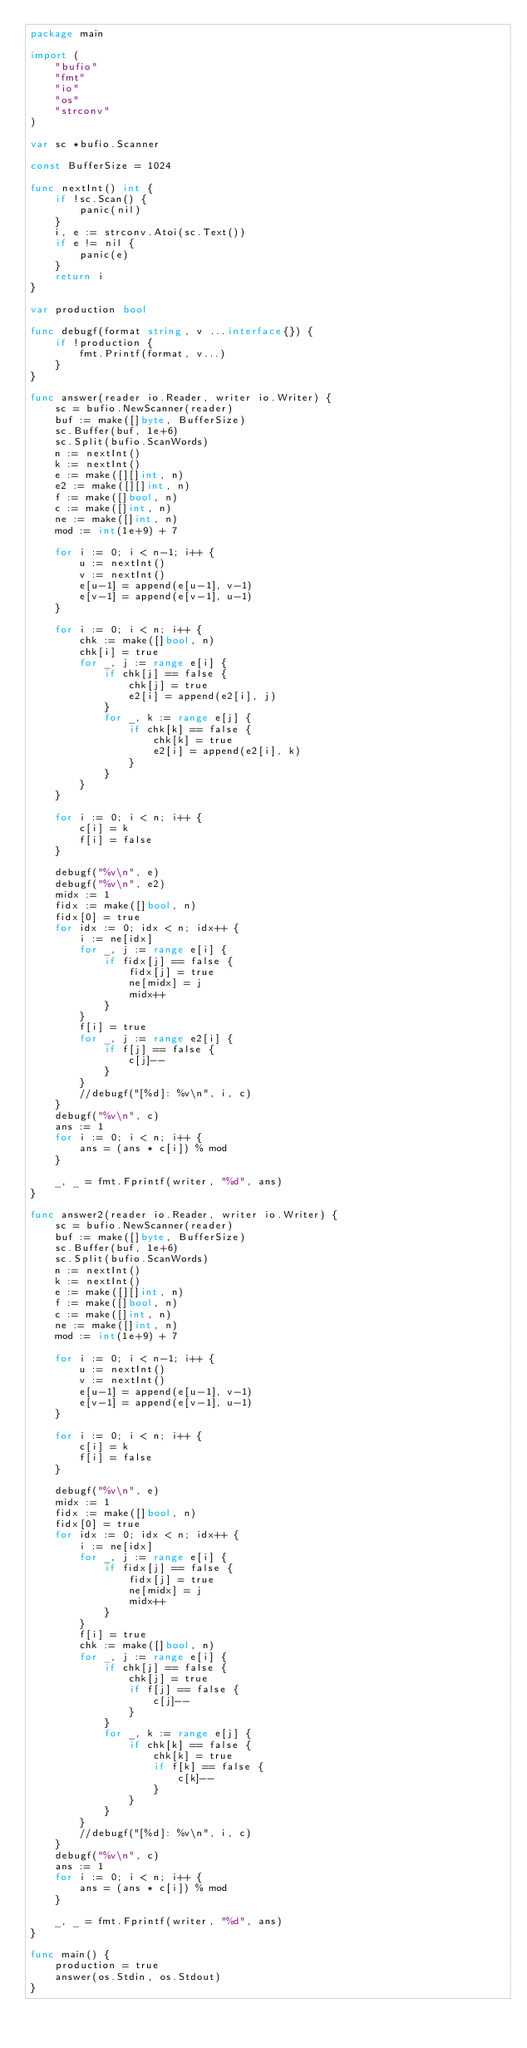Convert code to text. <code><loc_0><loc_0><loc_500><loc_500><_Go_>package main

import (
	"bufio"
	"fmt"
	"io"
	"os"
	"strconv"
)

var sc *bufio.Scanner

const BufferSize = 1024

func nextInt() int {
	if !sc.Scan() {
		panic(nil)
	}
	i, e := strconv.Atoi(sc.Text())
	if e != nil {
		panic(e)
	}
	return i
}

var production bool

func debugf(format string, v ...interface{}) {
	if !production {
		fmt.Printf(format, v...)
	}
}

func answer(reader io.Reader, writer io.Writer) {
	sc = bufio.NewScanner(reader)
	buf := make([]byte, BufferSize)
	sc.Buffer(buf, 1e+6)
	sc.Split(bufio.ScanWords)
	n := nextInt()
	k := nextInt()
	e := make([][]int, n)
	e2 := make([][]int, n)
	f := make([]bool, n)
	c := make([]int, n)
	ne := make([]int, n)
	mod := int(1e+9) + 7

	for i := 0; i < n-1; i++ {
		u := nextInt()
		v := nextInt()
		e[u-1] = append(e[u-1], v-1)
		e[v-1] = append(e[v-1], u-1)
	}

	for i := 0; i < n; i++ {
		chk := make([]bool, n)
		chk[i] = true
		for _, j := range e[i] {
			if chk[j] == false {
				chk[j] = true
				e2[i] = append(e2[i], j)
			}
			for _, k := range e[j] {
				if chk[k] == false {
					chk[k] = true
					e2[i] = append(e2[i], k)
				}
			}
		}
	}

	for i := 0; i < n; i++ {
		c[i] = k
		f[i] = false
	}

	debugf("%v\n", e)
	debugf("%v\n", e2)
	midx := 1
	fidx := make([]bool, n)
	fidx[0] = true
	for idx := 0; idx < n; idx++ {
		i := ne[idx]
		for _, j := range e[i] {
			if fidx[j] == false {
				fidx[j] = true
				ne[midx] = j
				midx++
			}
		}
		f[i] = true
		for _, j := range e2[i] {
			if f[j] == false {
				c[j]--
			}
		}
		//debugf("[%d]: %v\n", i, c)
	}
	debugf("%v\n", c)
	ans := 1
	for i := 0; i < n; i++ {
		ans = (ans * c[i]) % mod
	}

	_, _ = fmt.Fprintf(writer, "%d", ans)
}

func answer2(reader io.Reader, writer io.Writer) {
	sc = bufio.NewScanner(reader)
	buf := make([]byte, BufferSize)
	sc.Buffer(buf, 1e+6)
	sc.Split(bufio.ScanWords)
	n := nextInt()
	k := nextInt()
	e := make([][]int, n)
	f := make([]bool, n)
	c := make([]int, n)
	ne := make([]int, n)
	mod := int(1e+9) + 7

	for i := 0; i < n-1; i++ {
		u := nextInt()
		v := nextInt()
		e[u-1] = append(e[u-1], v-1)
		e[v-1] = append(e[v-1], u-1)
	}

	for i := 0; i < n; i++ {
		c[i] = k
		f[i] = false
	}

	debugf("%v\n", e)
	midx := 1
	fidx := make([]bool, n)
	fidx[0] = true
	for idx := 0; idx < n; idx++ {
		i := ne[idx]
		for _, j := range e[i] {
			if fidx[j] == false {
				fidx[j] = true
				ne[midx] = j
				midx++
			}
		}
		f[i] = true
		chk := make([]bool, n)
		for _, j := range e[i] {
			if chk[j] == false {
				chk[j] = true
				if f[j] == false {
					c[j]--
				}
			}
			for _, k := range e[j] {
				if chk[k] == false {
					chk[k] = true
					if f[k] == false {
						c[k]--
					}
				}
			}
		}
		//debugf("[%d]: %v\n", i, c)
	}
	debugf("%v\n", c)
	ans := 1
	for i := 0; i < n; i++ {
		ans = (ans * c[i]) % mod
	}

	_, _ = fmt.Fprintf(writer, "%d", ans)
}

func main() {
	production = true
	answer(os.Stdin, os.Stdout)
}
</code> 